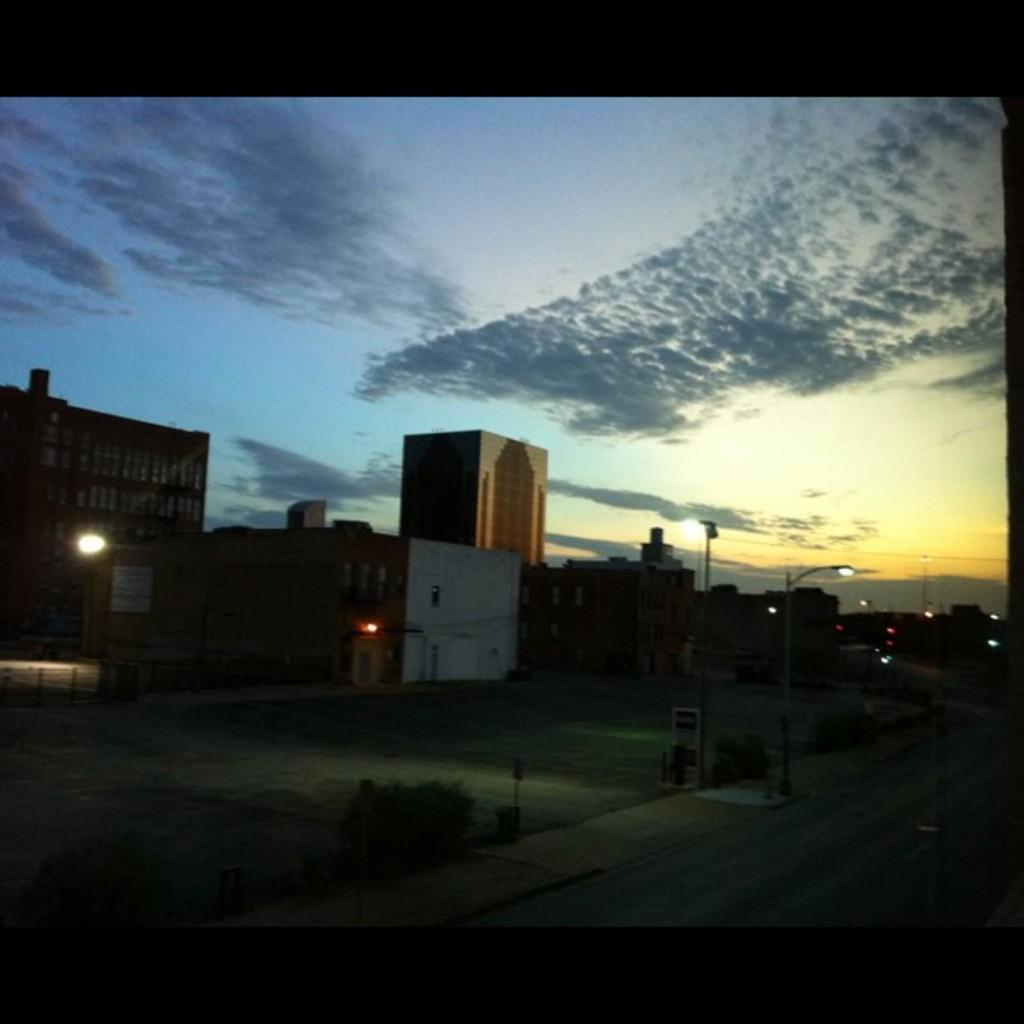What type of structures can be seen in the image? There are buildings in the image. What type of lighting is present along the road in the image? Street lights are visible in the image. What type of vegetation is present in the image? There are bushes in the image. What type of pathway is present in the image? There is a road in the image. What can be seen in the sky in the image? Clouds are present in the sky. Where are the jewels hidden in the image? There are no jewels present in the image. How many cars are parked along the road in the image? There is no mention of cars in the image, so we cannot determine the number of cars. 